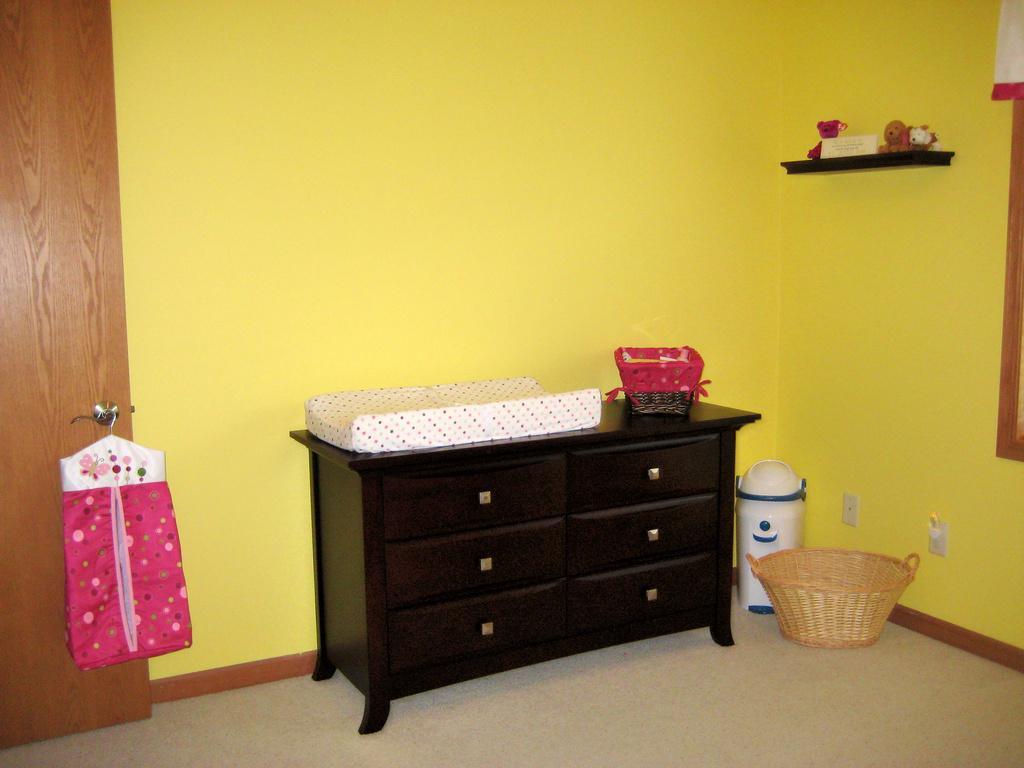Describe this image in one or two sentences. This image is taken indoors. At the bottom of the image there is a floor. In the background there is a wall and there is a shelf with a few toys on it. On the left side of the image there is a door. In the middle of the image there is a table with a basket an object on it there is a basket and an object on the floor. 